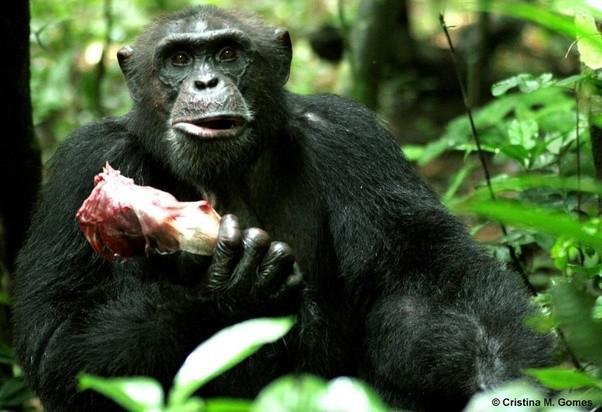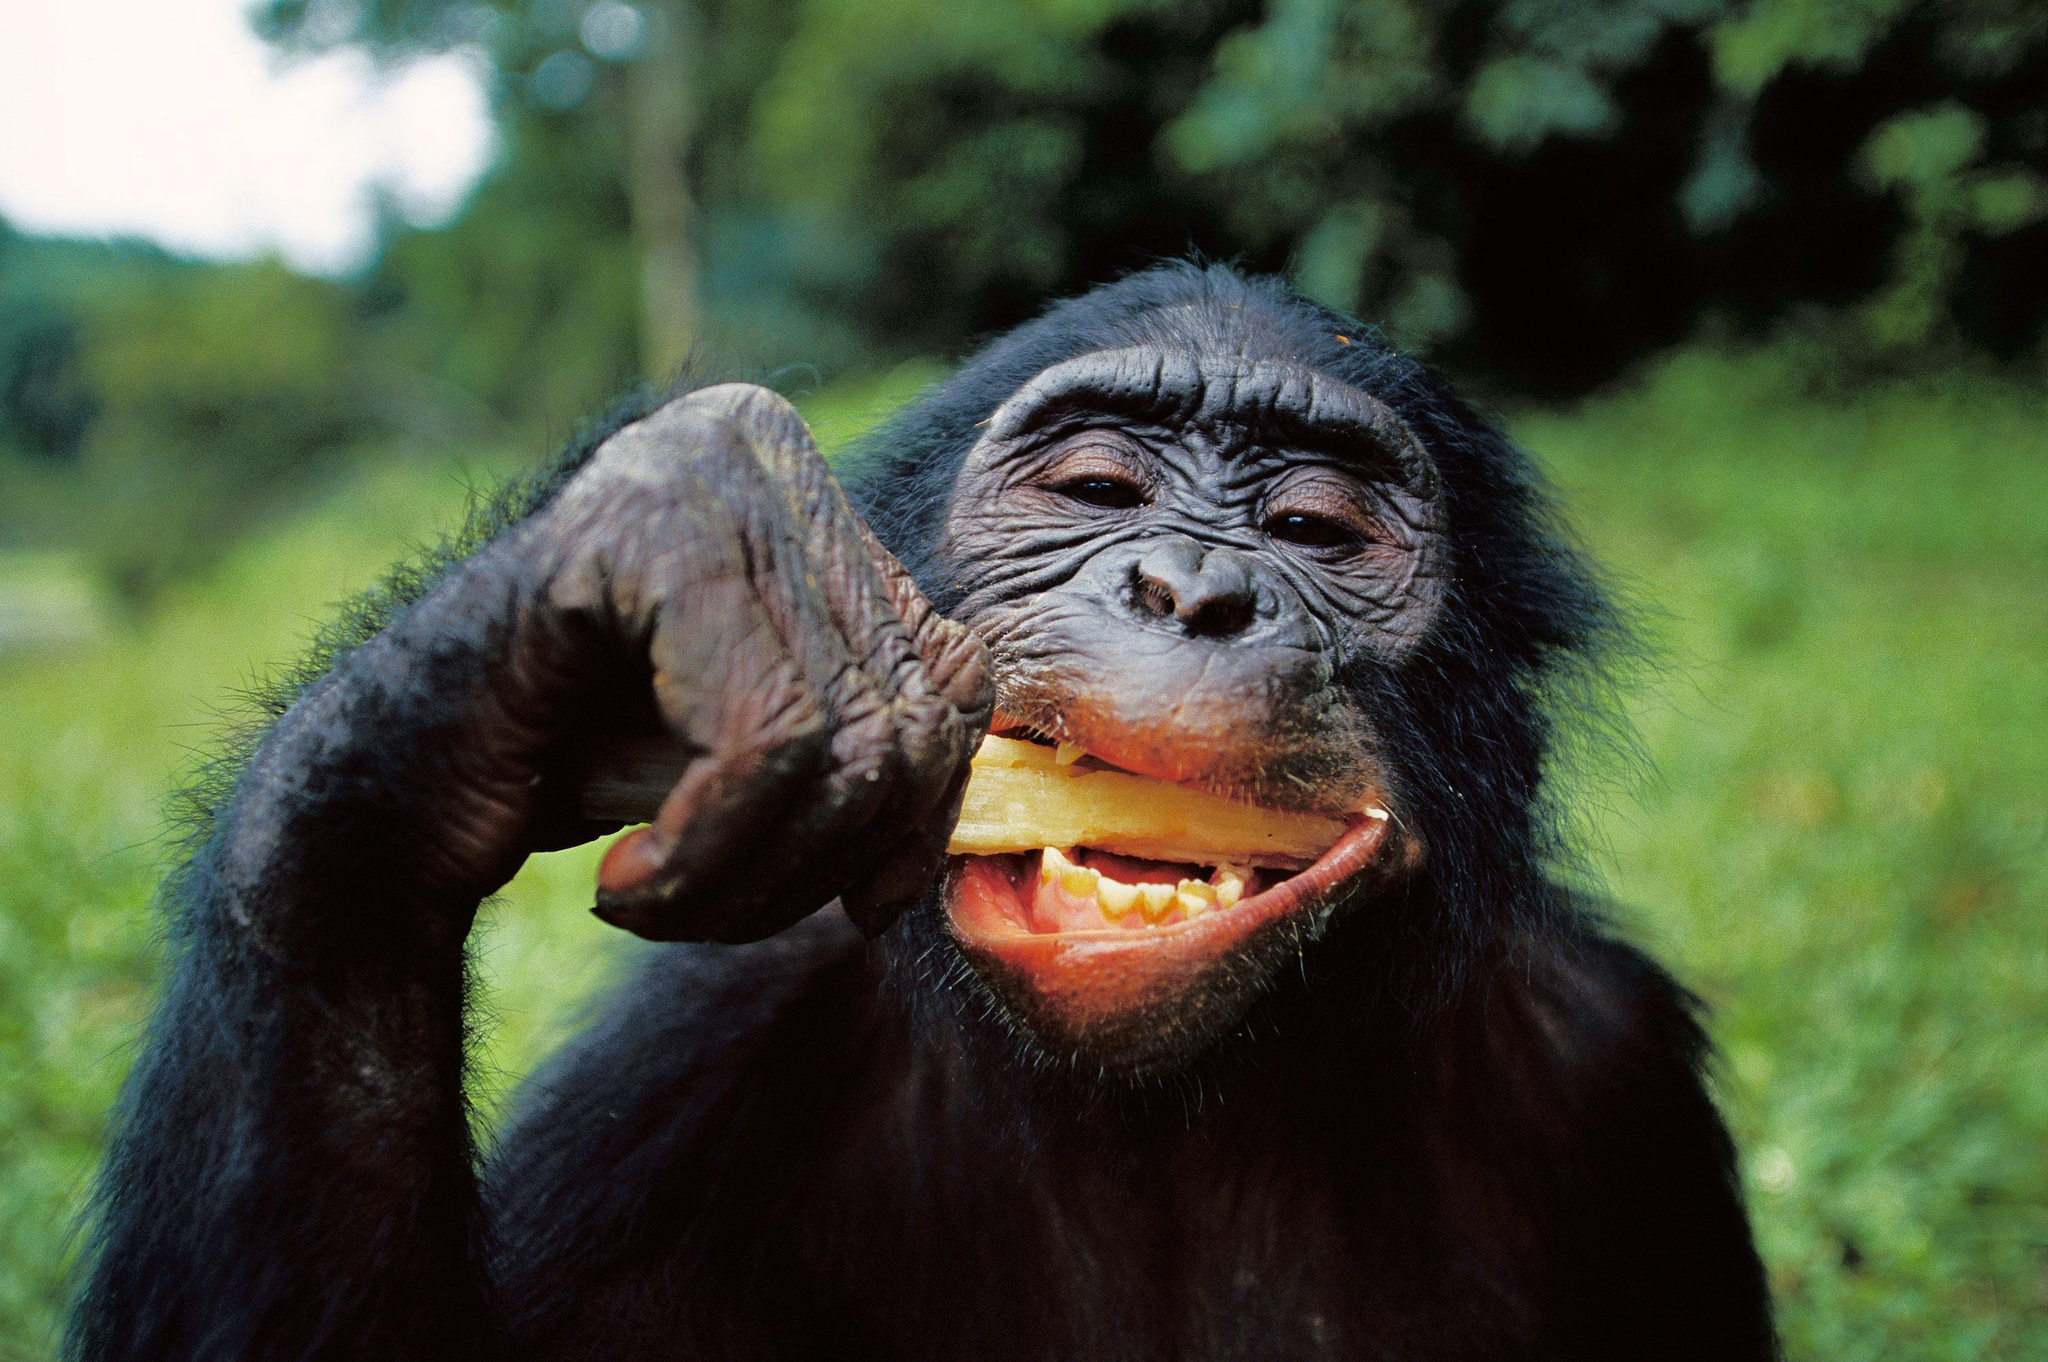The first image is the image on the left, the second image is the image on the right. Evaluate the accuracy of this statement regarding the images: "At least one chimp has something to eat in each image, and no chimp is using cutlery to eat.". Is it true? Answer yes or no. Yes. 